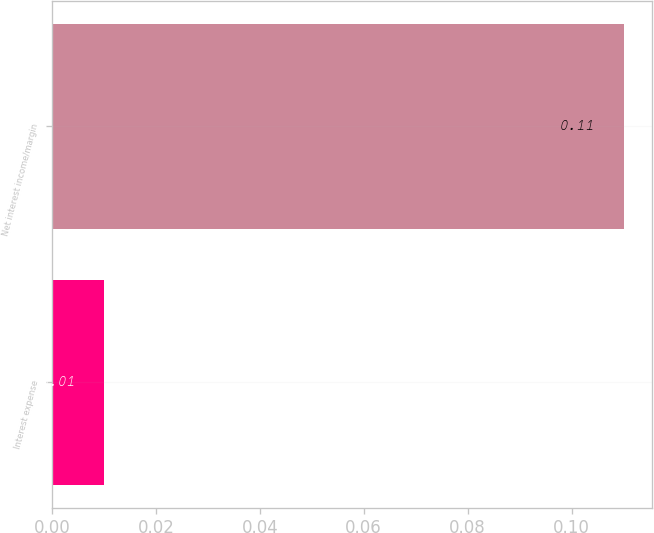Convert chart. <chart><loc_0><loc_0><loc_500><loc_500><bar_chart><fcel>Interest expense<fcel>Net interest income/margin<nl><fcel>0.01<fcel>0.11<nl></chart> 